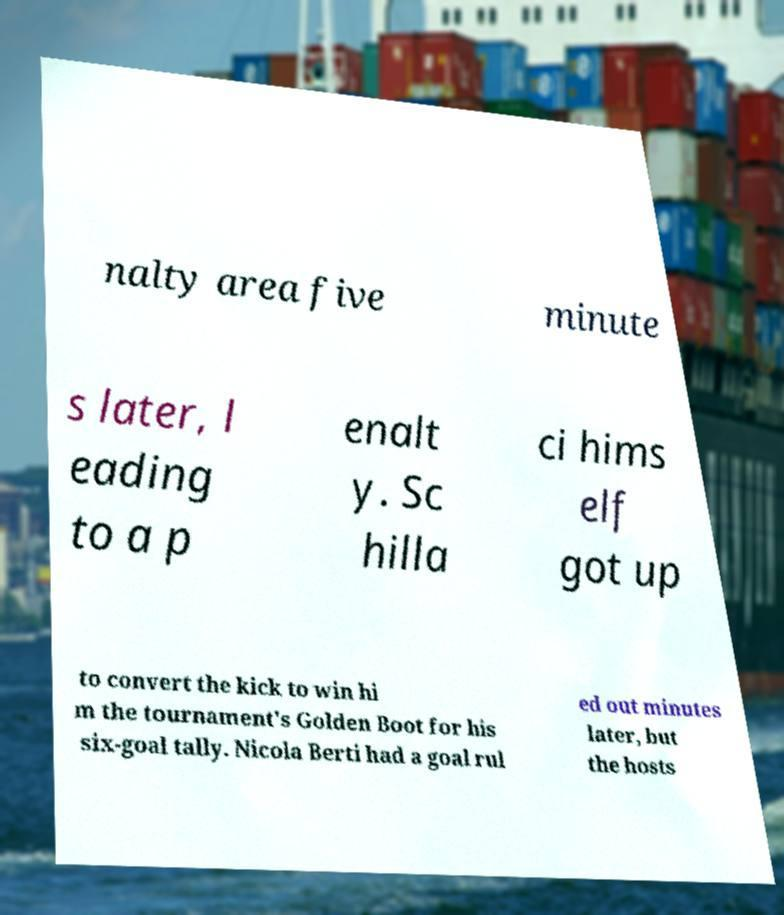I need the written content from this picture converted into text. Can you do that? nalty area five minute s later, l eading to a p enalt y. Sc hilla ci hims elf got up to convert the kick to win hi m the tournament's Golden Boot for his six-goal tally. Nicola Berti had a goal rul ed out minutes later, but the hosts 